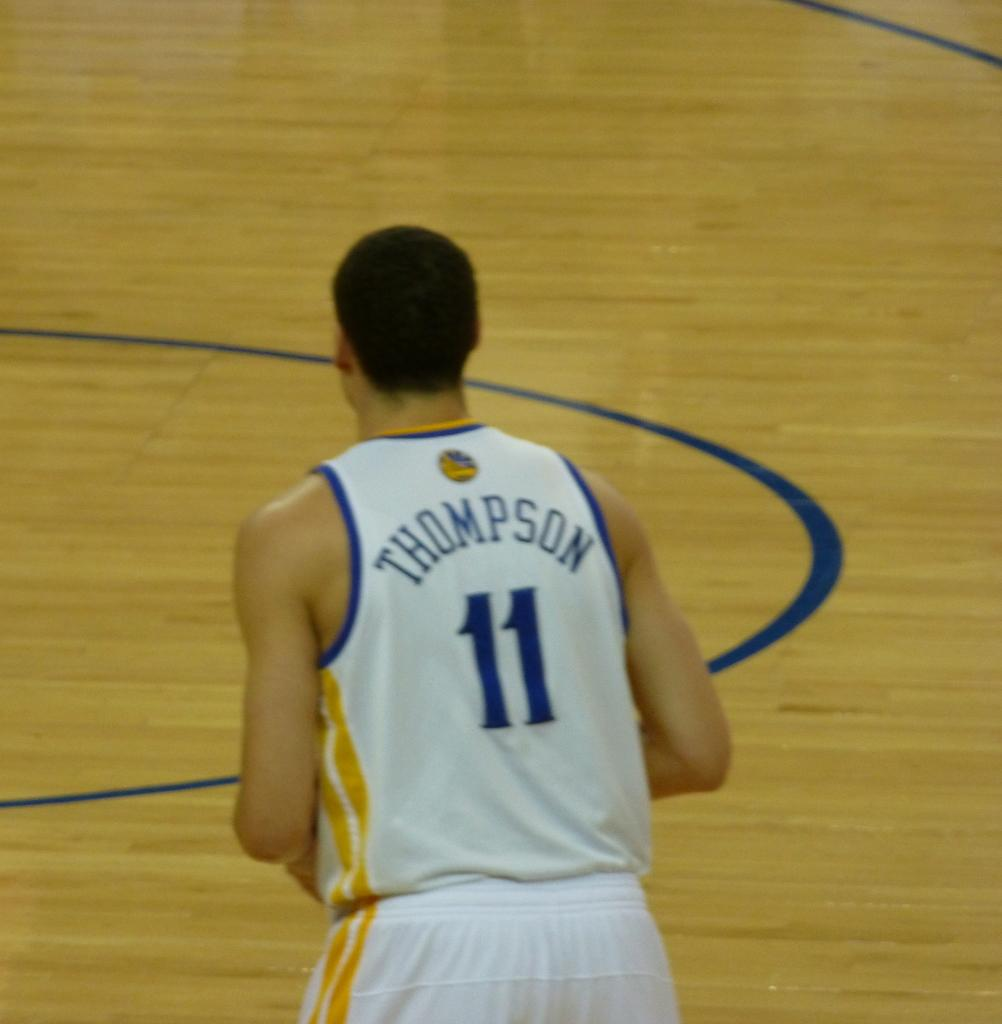<image>
Offer a succinct explanation of the picture presented. a player with the name Thompson on the court 